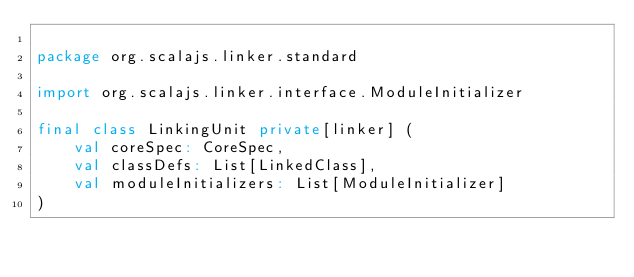<code> <loc_0><loc_0><loc_500><loc_500><_Scala_>
package org.scalajs.linker.standard

import org.scalajs.linker.interface.ModuleInitializer

final class LinkingUnit private[linker] (
    val coreSpec: CoreSpec,
    val classDefs: List[LinkedClass],
    val moduleInitializers: List[ModuleInitializer]
)
</code> 